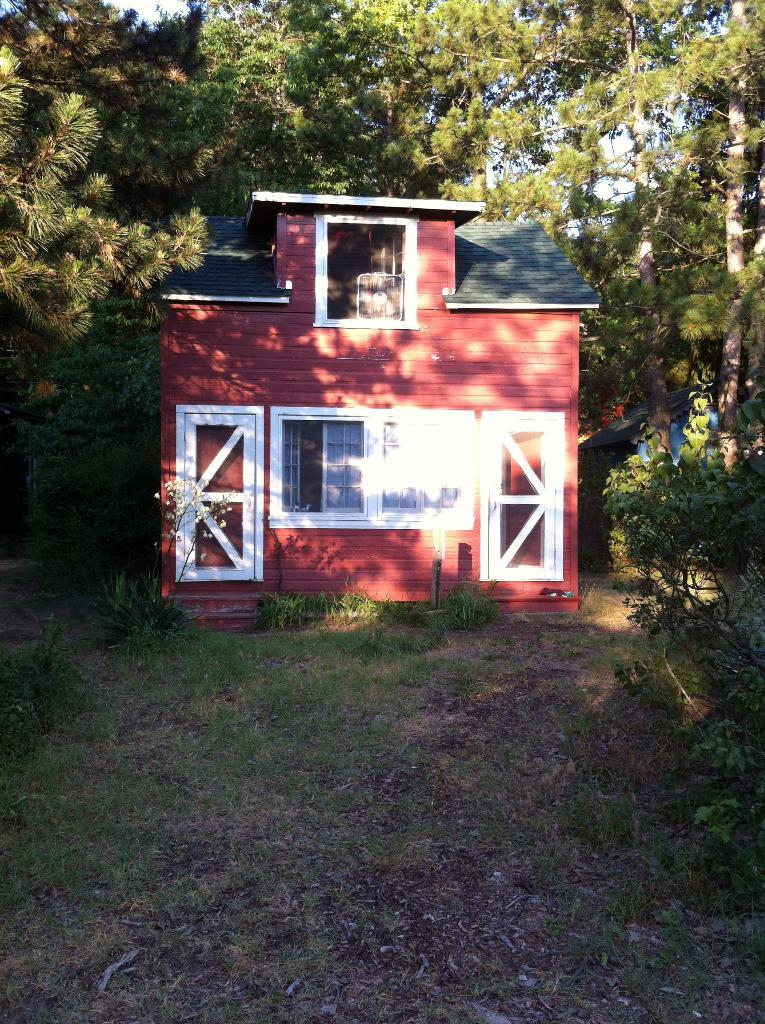What type of vegetation is present at the bottom of the image? There is grass and leaves on the ground at the bottom of the image. What is the main structure in the middle of the image? There is a house in the middle of the image. What features can be seen on the house? The house has windows and doors. What can be seen in the background of the image? There are trees, houses, and the sky visible in the background of the image. What type of beef is being served at the house in the image? There is no beef present in the image; it only shows a house with windows and doors, surrounded by trees and other houses. Is there a bear visible in the image? No, there is no bear present in the image. 